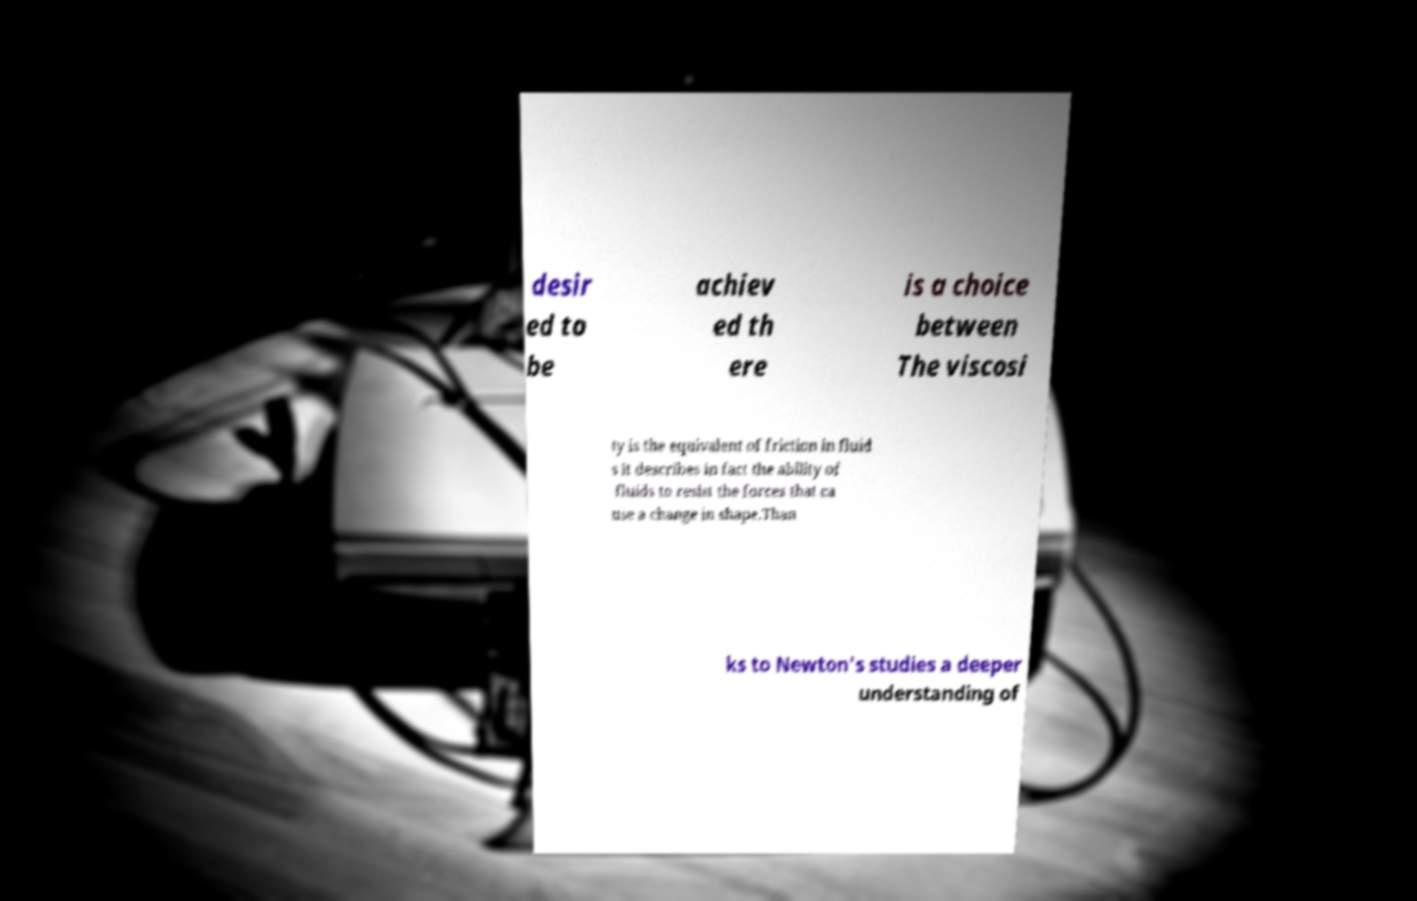I need the written content from this picture converted into text. Can you do that? desir ed to be achiev ed th ere is a choice between The viscosi ty is the equivalent of friction in fluid s it describes in fact the ability of fluids to resist the forces that ca use a change in shape.Than ks to Newton's studies a deeper understanding of 